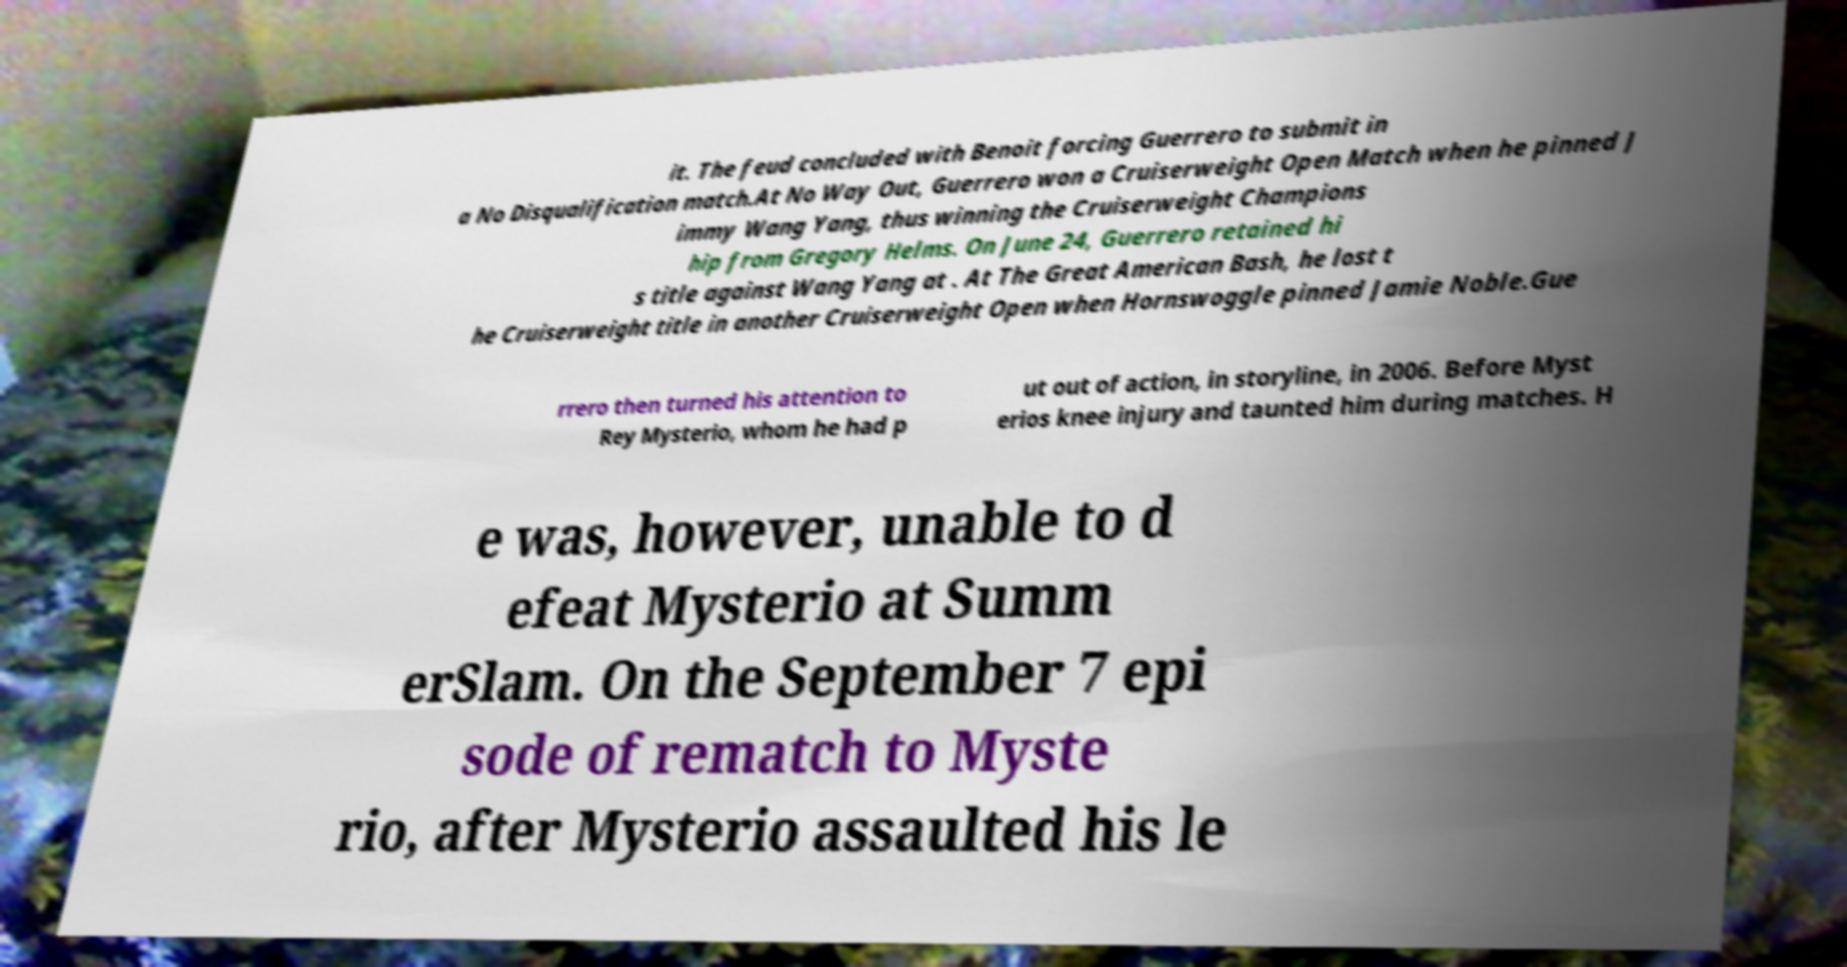Can you read and provide the text displayed in the image?This photo seems to have some interesting text. Can you extract and type it out for me? it. The feud concluded with Benoit forcing Guerrero to submit in a No Disqualification match.At No Way Out, Guerrero won a Cruiserweight Open Match when he pinned J immy Wang Yang, thus winning the Cruiserweight Champions hip from Gregory Helms. On June 24, Guerrero retained hi s title against Wang Yang at . At The Great American Bash, he lost t he Cruiserweight title in another Cruiserweight Open when Hornswoggle pinned Jamie Noble.Gue rrero then turned his attention to Rey Mysterio, whom he had p ut out of action, in storyline, in 2006. Before Myst erios knee injury and taunted him during matches. H e was, however, unable to d efeat Mysterio at Summ erSlam. On the September 7 epi sode of rematch to Myste rio, after Mysterio assaulted his le 